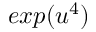Convert formula to latex. <formula><loc_0><loc_0><loc_500><loc_500>e x p ( u ^ { 4 } )</formula> 